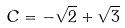Convert formula to latex. <formula><loc_0><loc_0><loc_500><loc_500>C = - \sqrt { 2 } + \sqrt { 3 }</formula> 